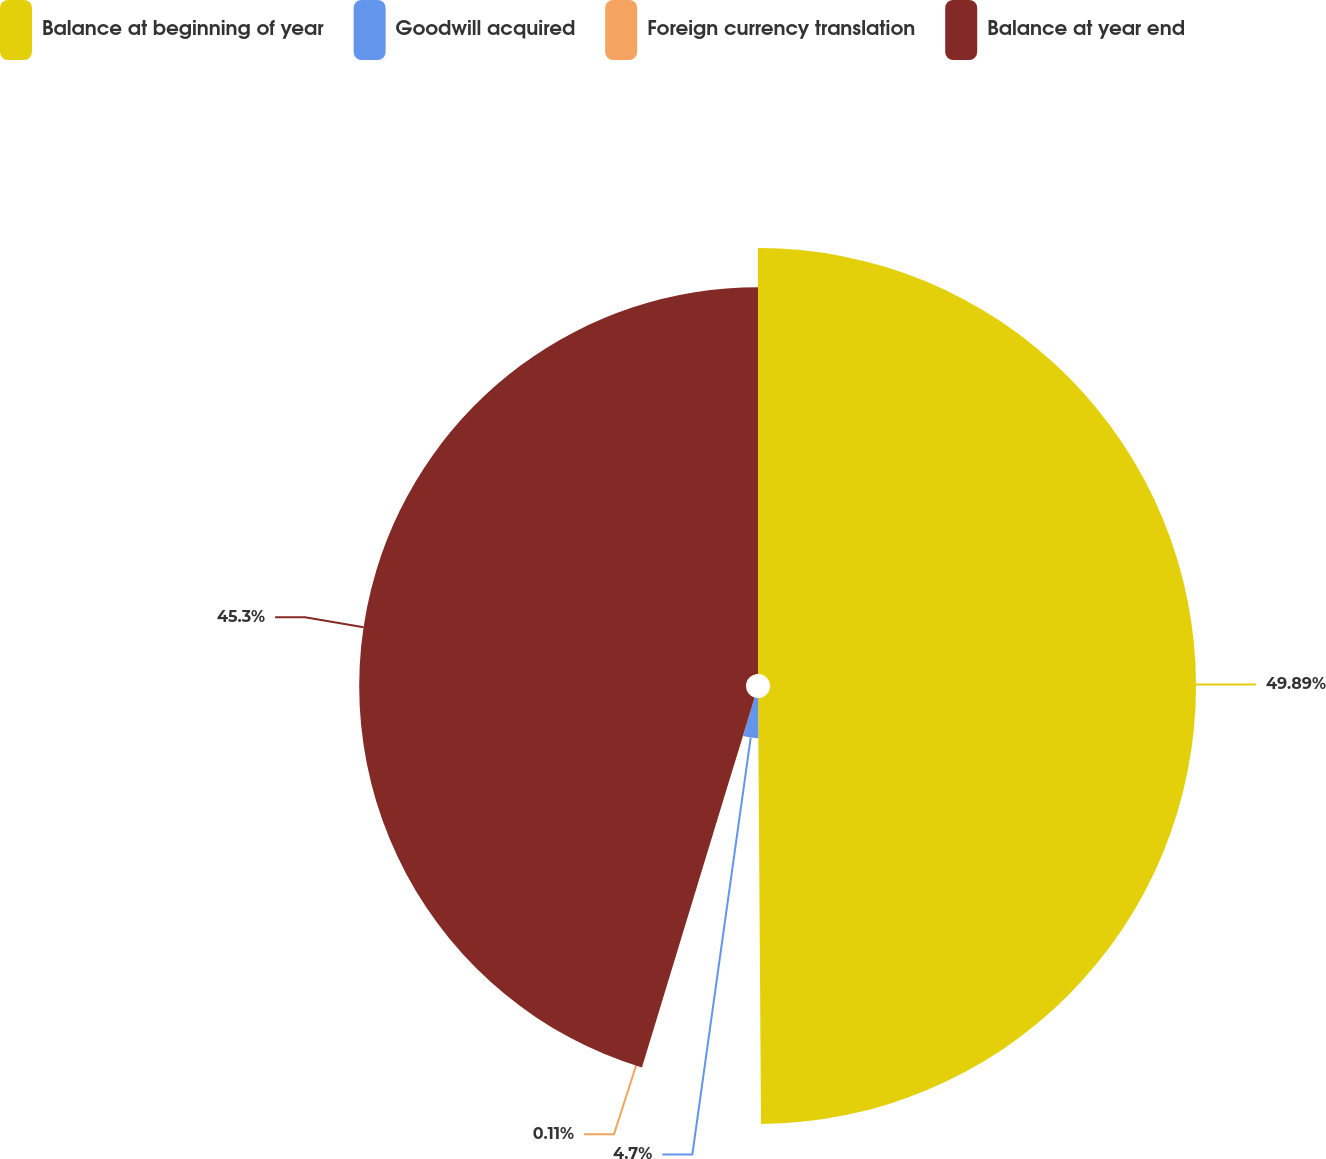<chart> <loc_0><loc_0><loc_500><loc_500><pie_chart><fcel>Balance at beginning of year<fcel>Goodwill acquired<fcel>Foreign currency translation<fcel>Balance at year end<nl><fcel>49.89%<fcel>4.7%<fcel>0.11%<fcel>45.3%<nl></chart> 